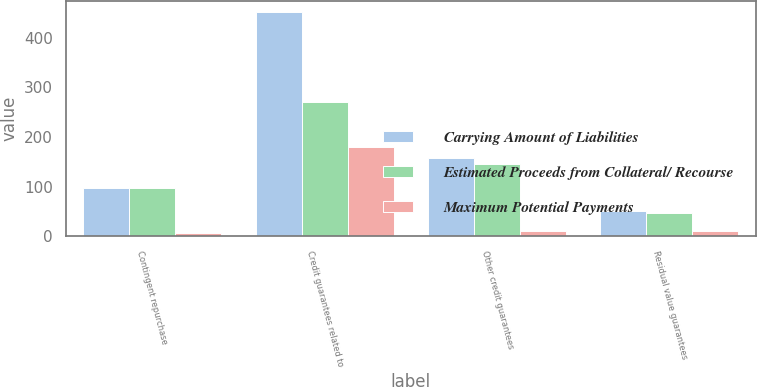Convert chart to OTSL. <chart><loc_0><loc_0><loc_500><loc_500><stacked_bar_chart><ecel><fcel>Contingent repurchase<fcel>Credit guarantees related to<fcel>Other credit guarantees<fcel>Residual value guarantees<nl><fcel>Carrying Amount of Liabilities<fcel>98<fcel>451<fcel>158<fcel>51<nl><fcel>Estimated Proceeds from Collateral/ Recourse<fcel>98<fcel>271<fcel>145<fcel>47<nl><fcel>Maximum Potential Payments<fcel>7<fcel>180<fcel>11<fcel>10<nl></chart> 